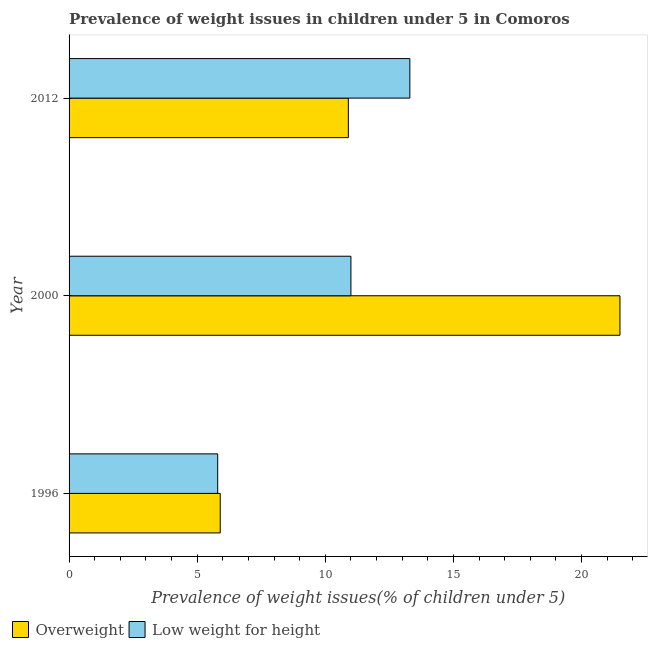How many different coloured bars are there?
Your answer should be very brief. 2. How many groups of bars are there?
Provide a short and direct response. 3. Are the number of bars per tick equal to the number of legend labels?
Offer a very short reply. Yes. What is the label of the 2nd group of bars from the top?
Your answer should be compact. 2000. What is the percentage of underweight children in 2012?
Provide a short and direct response. 13.3. Across all years, what is the maximum percentage of underweight children?
Your answer should be compact. 13.3. Across all years, what is the minimum percentage of underweight children?
Provide a succinct answer. 5.8. In which year was the percentage of overweight children maximum?
Your response must be concise. 2000. What is the total percentage of overweight children in the graph?
Offer a very short reply. 38.3. What is the difference between the percentage of overweight children in 1996 and the percentage of underweight children in 2012?
Ensure brevity in your answer.  -7.4. What is the average percentage of overweight children per year?
Offer a very short reply. 12.77. In the year 2000, what is the difference between the percentage of underweight children and percentage of overweight children?
Offer a terse response. -10.5. What is the ratio of the percentage of underweight children in 1996 to that in 2012?
Provide a short and direct response. 0.44. Is the percentage of underweight children in 1996 less than that in 2000?
Give a very brief answer. Yes. Is the difference between the percentage of underweight children in 2000 and 2012 greater than the difference between the percentage of overweight children in 2000 and 2012?
Provide a succinct answer. No. What is the difference between the highest and the second highest percentage of overweight children?
Your answer should be compact. 10.6. In how many years, is the percentage of underweight children greater than the average percentage of underweight children taken over all years?
Your response must be concise. 2. Is the sum of the percentage of overweight children in 2000 and 2012 greater than the maximum percentage of underweight children across all years?
Make the answer very short. Yes. What does the 2nd bar from the top in 1996 represents?
Your response must be concise. Overweight. What does the 1st bar from the bottom in 1996 represents?
Provide a short and direct response. Overweight. How many bars are there?
Offer a very short reply. 6. Are all the bars in the graph horizontal?
Provide a succinct answer. Yes. How many years are there in the graph?
Ensure brevity in your answer.  3. Does the graph contain any zero values?
Your answer should be very brief. No. Does the graph contain grids?
Keep it short and to the point. No. How many legend labels are there?
Ensure brevity in your answer.  2. How are the legend labels stacked?
Keep it short and to the point. Horizontal. What is the title of the graph?
Offer a terse response. Prevalence of weight issues in children under 5 in Comoros. What is the label or title of the X-axis?
Give a very brief answer. Prevalence of weight issues(% of children under 5). What is the Prevalence of weight issues(% of children under 5) in Overweight in 1996?
Your response must be concise. 5.9. What is the Prevalence of weight issues(% of children under 5) of Low weight for height in 1996?
Keep it short and to the point. 5.8. What is the Prevalence of weight issues(% of children under 5) of Low weight for height in 2000?
Offer a terse response. 11. What is the Prevalence of weight issues(% of children under 5) of Overweight in 2012?
Your response must be concise. 10.9. What is the Prevalence of weight issues(% of children under 5) of Low weight for height in 2012?
Provide a short and direct response. 13.3. Across all years, what is the maximum Prevalence of weight issues(% of children under 5) in Overweight?
Keep it short and to the point. 21.5. Across all years, what is the maximum Prevalence of weight issues(% of children under 5) of Low weight for height?
Your response must be concise. 13.3. Across all years, what is the minimum Prevalence of weight issues(% of children under 5) of Overweight?
Offer a terse response. 5.9. Across all years, what is the minimum Prevalence of weight issues(% of children under 5) of Low weight for height?
Offer a terse response. 5.8. What is the total Prevalence of weight issues(% of children under 5) of Overweight in the graph?
Offer a terse response. 38.3. What is the total Prevalence of weight issues(% of children under 5) of Low weight for height in the graph?
Your answer should be compact. 30.1. What is the difference between the Prevalence of weight issues(% of children under 5) of Overweight in 1996 and that in 2000?
Provide a short and direct response. -15.6. What is the difference between the Prevalence of weight issues(% of children under 5) in Overweight in 1996 and that in 2012?
Your answer should be compact. -5. What is the difference between the Prevalence of weight issues(% of children under 5) of Overweight in 2000 and that in 2012?
Your response must be concise. 10.6. What is the difference between the Prevalence of weight issues(% of children under 5) in Low weight for height in 2000 and that in 2012?
Provide a short and direct response. -2.3. What is the difference between the Prevalence of weight issues(% of children under 5) in Overweight in 2000 and the Prevalence of weight issues(% of children under 5) in Low weight for height in 2012?
Give a very brief answer. 8.2. What is the average Prevalence of weight issues(% of children under 5) in Overweight per year?
Your response must be concise. 12.77. What is the average Prevalence of weight issues(% of children under 5) of Low weight for height per year?
Offer a terse response. 10.03. In the year 2000, what is the difference between the Prevalence of weight issues(% of children under 5) of Overweight and Prevalence of weight issues(% of children under 5) of Low weight for height?
Keep it short and to the point. 10.5. What is the ratio of the Prevalence of weight issues(% of children under 5) in Overweight in 1996 to that in 2000?
Your response must be concise. 0.27. What is the ratio of the Prevalence of weight issues(% of children under 5) of Low weight for height in 1996 to that in 2000?
Your answer should be very brief. 0.53. What is the ratio of the Prevalence of weight issues(% of children under 5) in Overweight in 1996 to that in 2012?
Your answer should be very brief. 0.54. What is the ratio of the Prevalence of weight issues(% of children under 5) in Low weight for height in 1996 to that in 2012?
Give a very brief answer. 0.44. What is the ratio of the Prevalence of weight issues(% of children under 5) of Overweight in 2000 to that in 2012?
Give a very brief answer. 1.97. What is the ratio of the Prevalence of weight issues(% of children under 5) in Low weight for height in 2000 to that in 2012?
Keep it short and to the point. 0.83. What is the difference between the highest and the second highest Prevalence of weight issues(% of children under 5) of Overweight?
Make the answer very short. 10.6. What is the difference between the highest and the second highest Prevalence of weight issues(% of children under 5) of Low weight for height?
Offer a very short reply. 2.3. 